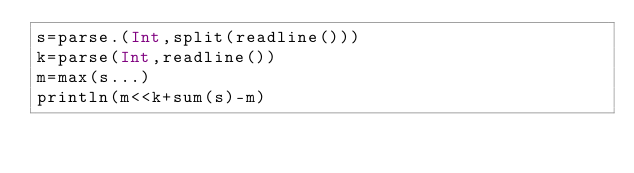<code> <loc_0><loc_0><loc_500><loc_500><_Julia_>s=parse.(Int,split(readline()))
k=parse(Int,readline())
m=max(s...)
println(m<<k+sum(s)-m)</code> 